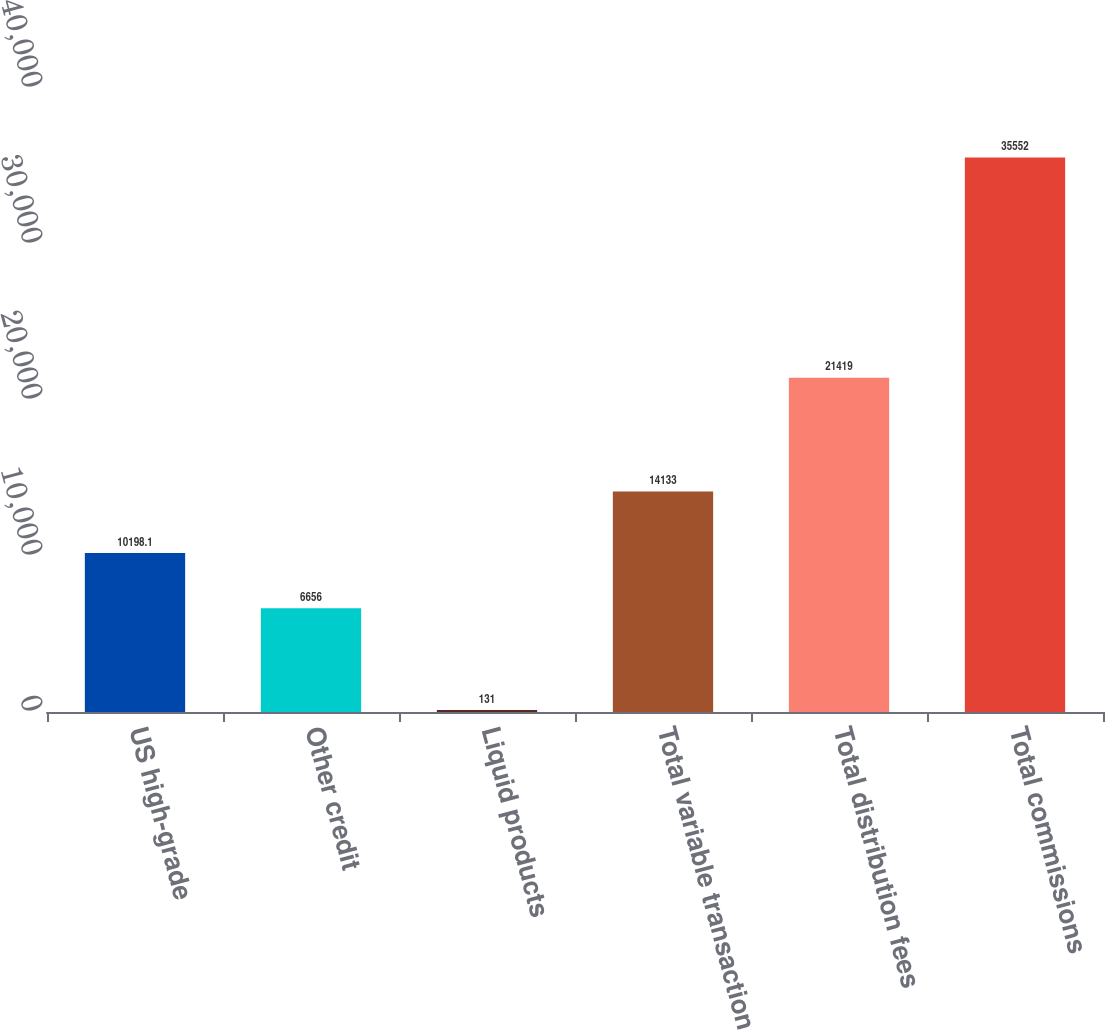Convert chart to OTSL. <chart><loc_0><loc_0><loc_500><loc_500><bar_chart><fcel>US high-grade<fcel>Other credit<fcel>Liquid products<fcel>Total variable transaction<fcel>Total distribution fees<fcel>Total commissions<nl><fcel>10198.1<fcel>6656<fcel>131<fcel>14133<fcel>21419<fcel>35552<nl></chart> 